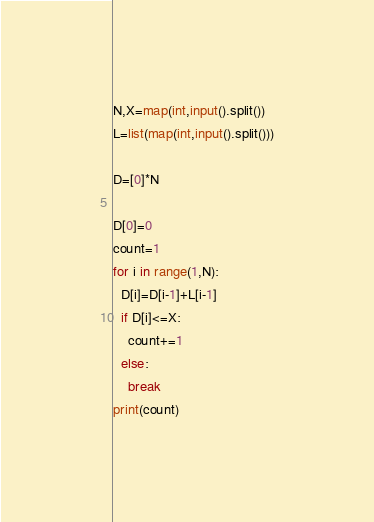<code> <loc_0><loc_0><loc_500><loc_500><_Python_>N,X=map(int,input().split())
L=list(map(int,input().split()))

D=[0]*N

D[0]=0
count=1
for i in range(1,N):
  D[i]=D[i-1]+L[i-1]
  if D[i]<=X:
    count+=1
  else:
    break
print(count)
</code> 